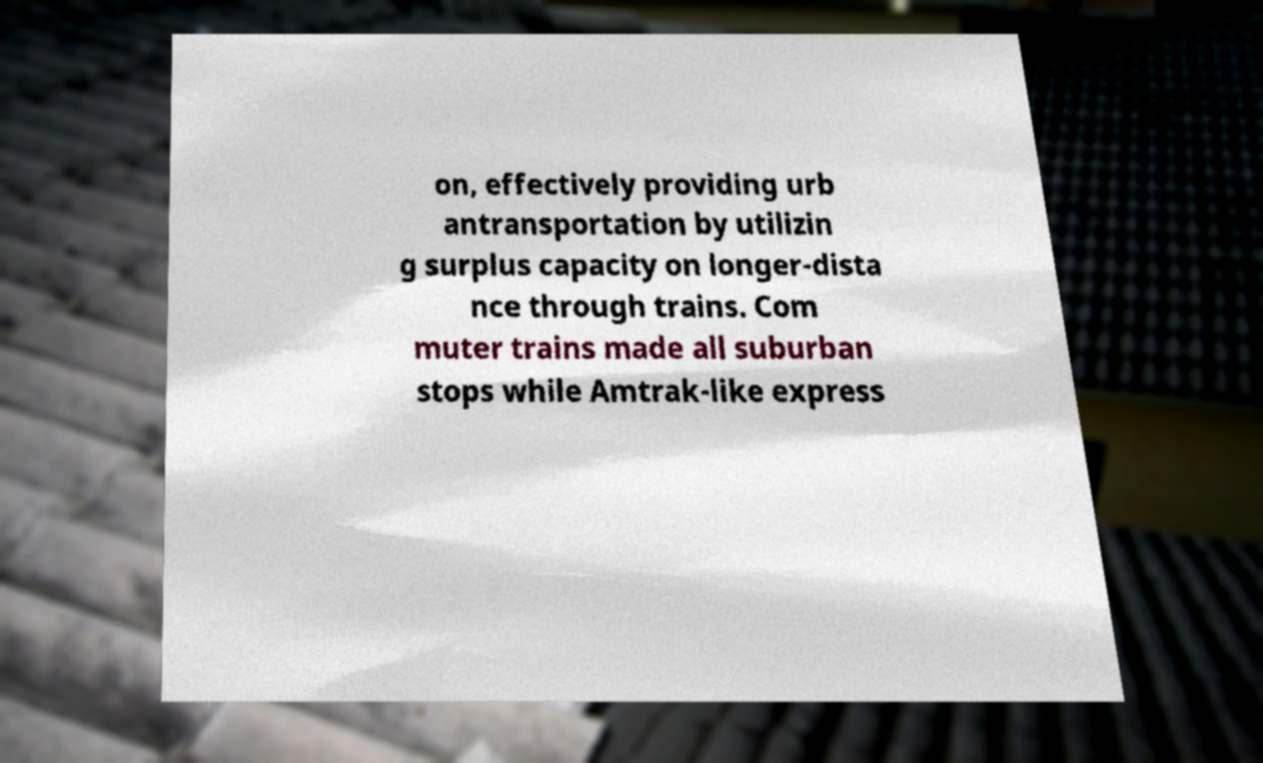What messages or text are displayed in this image? I need them in a readable, typed format. on, effectively providing urb antransportation by utilizin g surplus capacity on longer-dista nce through trains. Com muter trains made all suburban stops while Amtrak-like express 